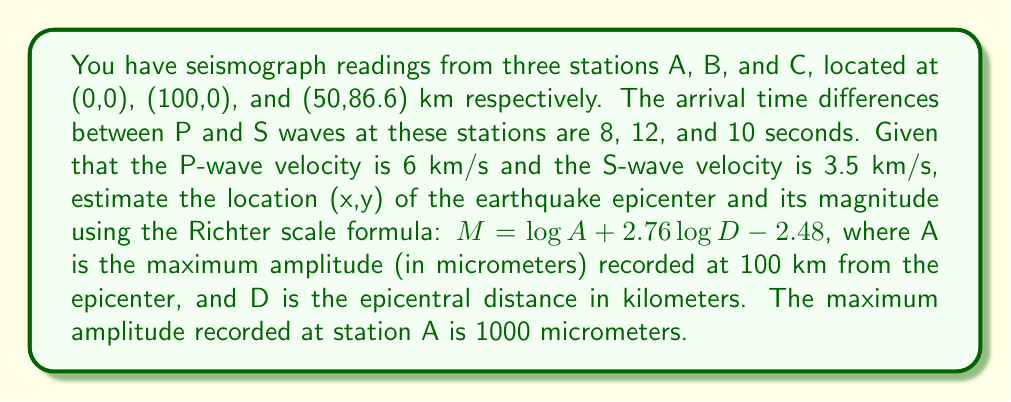Show me your answer to this math problem. 1. Calculate the epicentral distances for each station:
   Let $v_p = 6$ km/s and $v_s = 3.5$ km/s
   Distance = Time difference × (($v_p \times v_s$)/($v_p - v_s$))
   For A: $D_A = 8 \times ((6 \times 3.5)/(6 - 3.5)) = 67.2$ km
   For B: $D_B = 12 \times ((6 \times 3.5)/(6 - 3.5)) = 100.8$ km
   For C: $D_C = 10 \times ((6 \times 3.5)/(6 - 3.5)) = 84$ km

2. Use trilateration to find the epicenter:
   Set up equations for circles centered at each station:
   $(x^2 + y^2) = 67.2^2$
   $((x-100)^2 + y^2) = 100.8^2$
   $((x-50)^2 + (y-86.6)^2) = 84^2$

3. Solve the system of equations numerically (e.g., using Newton-Raphson method):
   Epicenter coordinates: $(x, y) \approx (33.6, 58.2)$ km

4. Calculate the epicentral distance for station A:
   $D = \sqrt{33.6^2 + 58.2^2} \approx 67.2$ km

5. Use the Richter scale formula to estimate the magnitude:
   $M = \log A + 2.76 \log D - 2.48$
   $M = \log 1000 + 2.76 \log 67.2 - 2.48$
   $M = 3 + 2.76 \times 1.827 - 2.48$
   $M \approx 5.56$
Answer: Epicenter: (33.6, 58.2) km; Magnitude: 5.56 